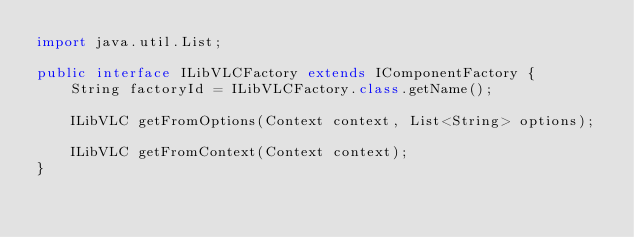<code> <loc_0><loc_0><loc_500><loc_500><_Java_>import java.util.List;

public interface ILibVLCFactory extends IComponentFactory {
    String factoryId = ILibVLCFactory.class.getName();

    ILibVLC getFromOptions(Context context, List<String> options);

    ILibVLC getFromContext(Context context);
}
</code> 